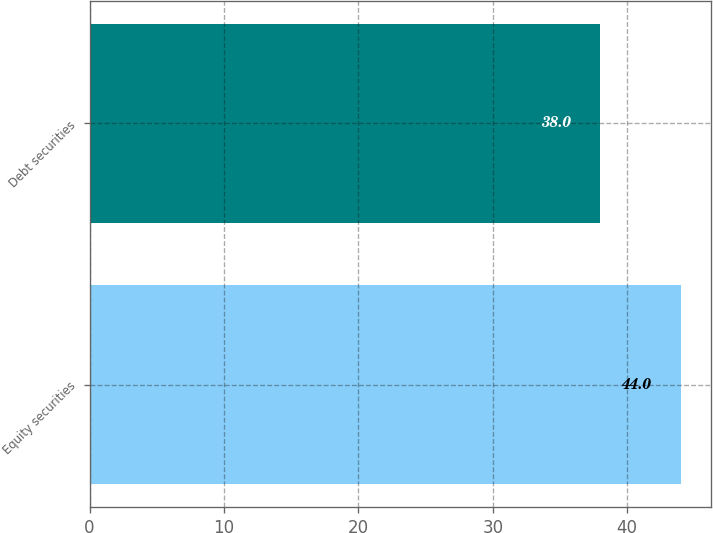<chart> <loc_0><loc_0><loc_500><loc_500><bar_chart><fcel>Equity securities<fcel>Debt securities<nl><fcel>44<fcel>38<nl></chart> 